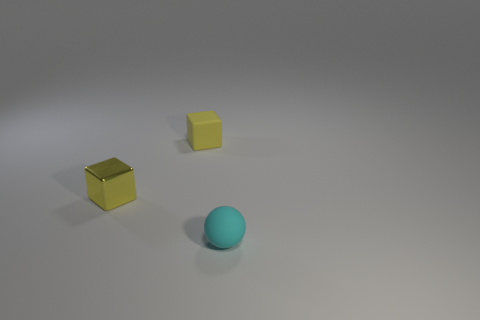Add 2 small yellow cubes. How many objects exist? 5 Subtract all blocks. How many objects are left? 1 Subtract all spheres. Subtract all matte things. How many objects are left? 0 Add 1 cyan matte spheres. How many cyan matte spheres are left? 2 Add 3 tiny yellow metal things. How many tiny yellow metal things exist? 4 Subtract 0 green cylinders. How many objects are left? 3 